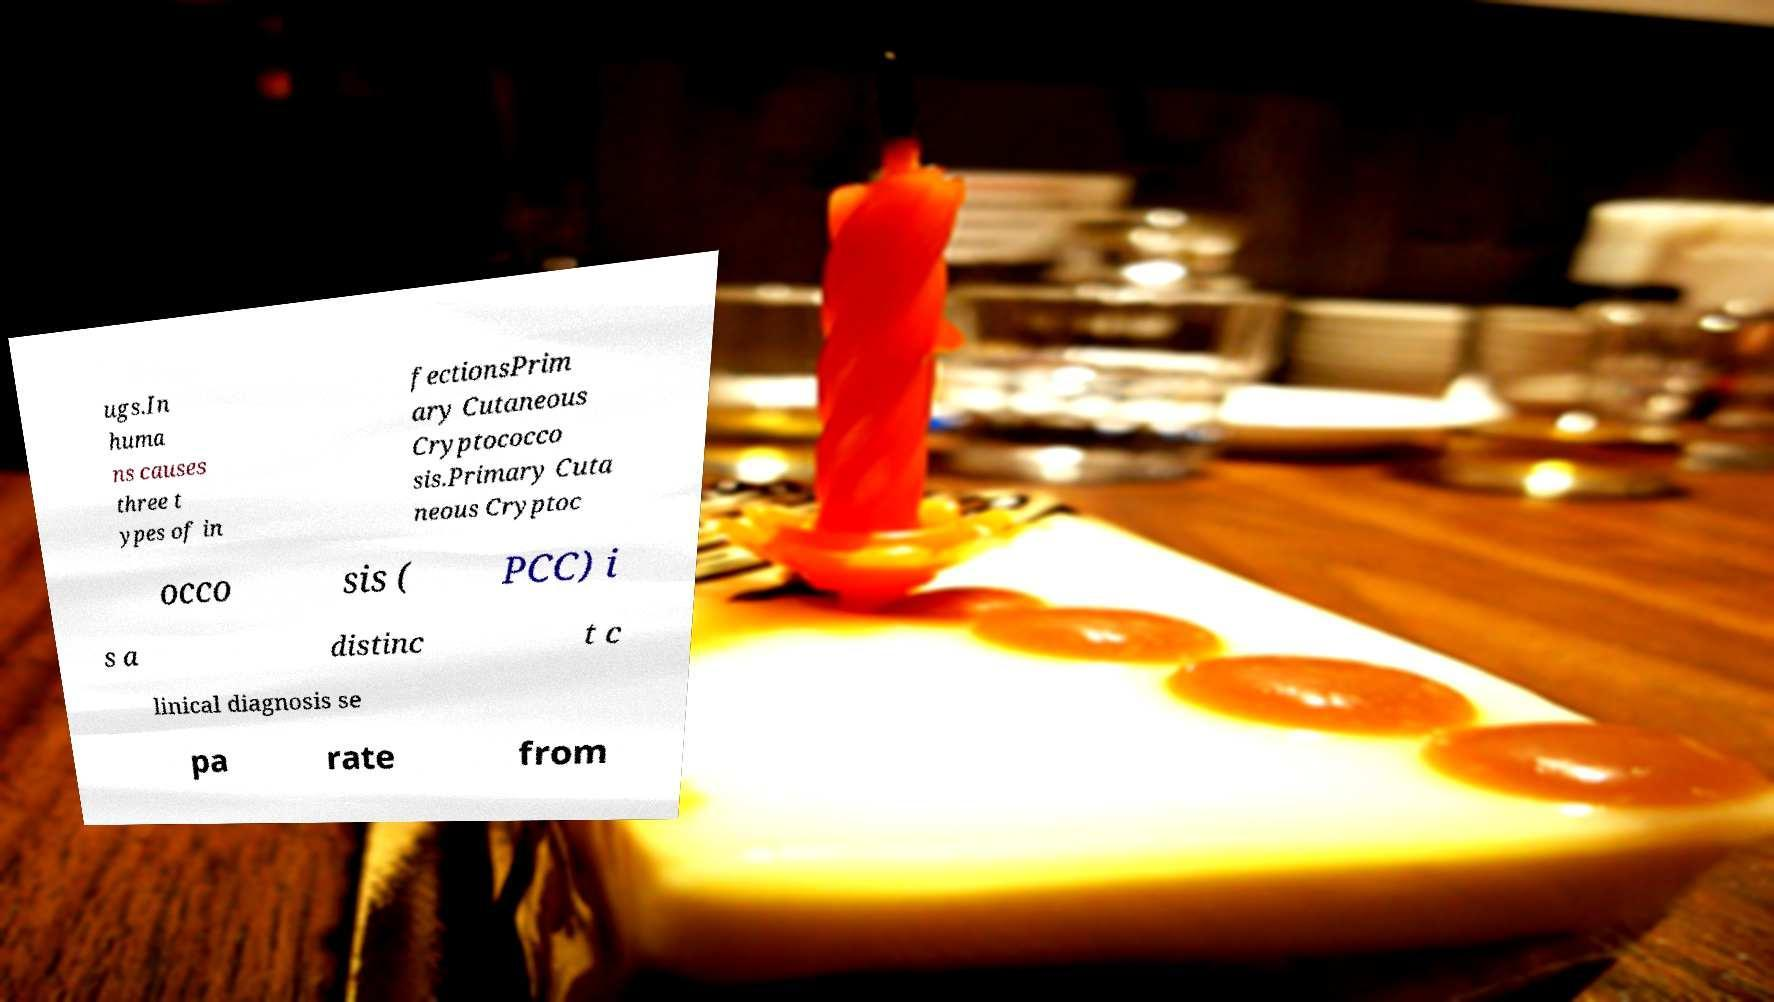Please identify and transcribe the text found in this image. ugs.In huma ns causes three t ypes of in fectionsPrim ary Cutaneous Cryptococco sis.Primary Cuta neous Cryptoc occo sis ( PCC) i s a distinc t c linical diagnosis se pa rate from 